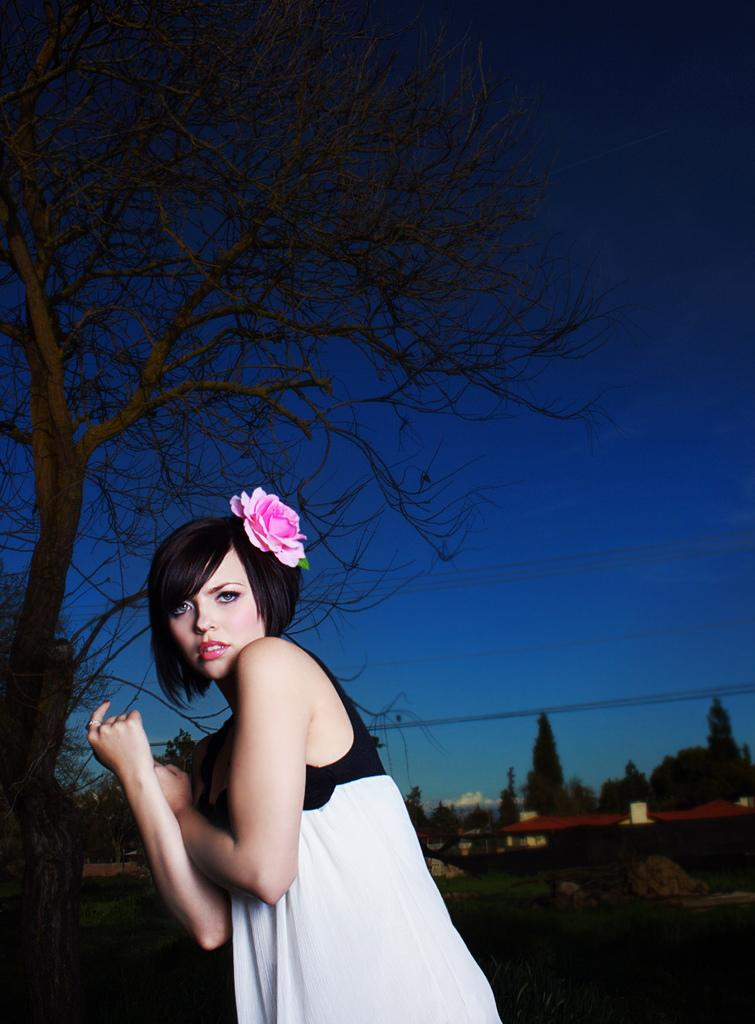Who is the main subject in the image? There is a lady in the center of the image. What can be seen in the background of the image? There are trees in the background of the image. What type of vegetation is at the bottom of the image? There is grass at the bottom of the image. What is visible at the top of the image? The sky is visible at the top of the image. How are the horses being used in the image? There are no horses present in the image. 